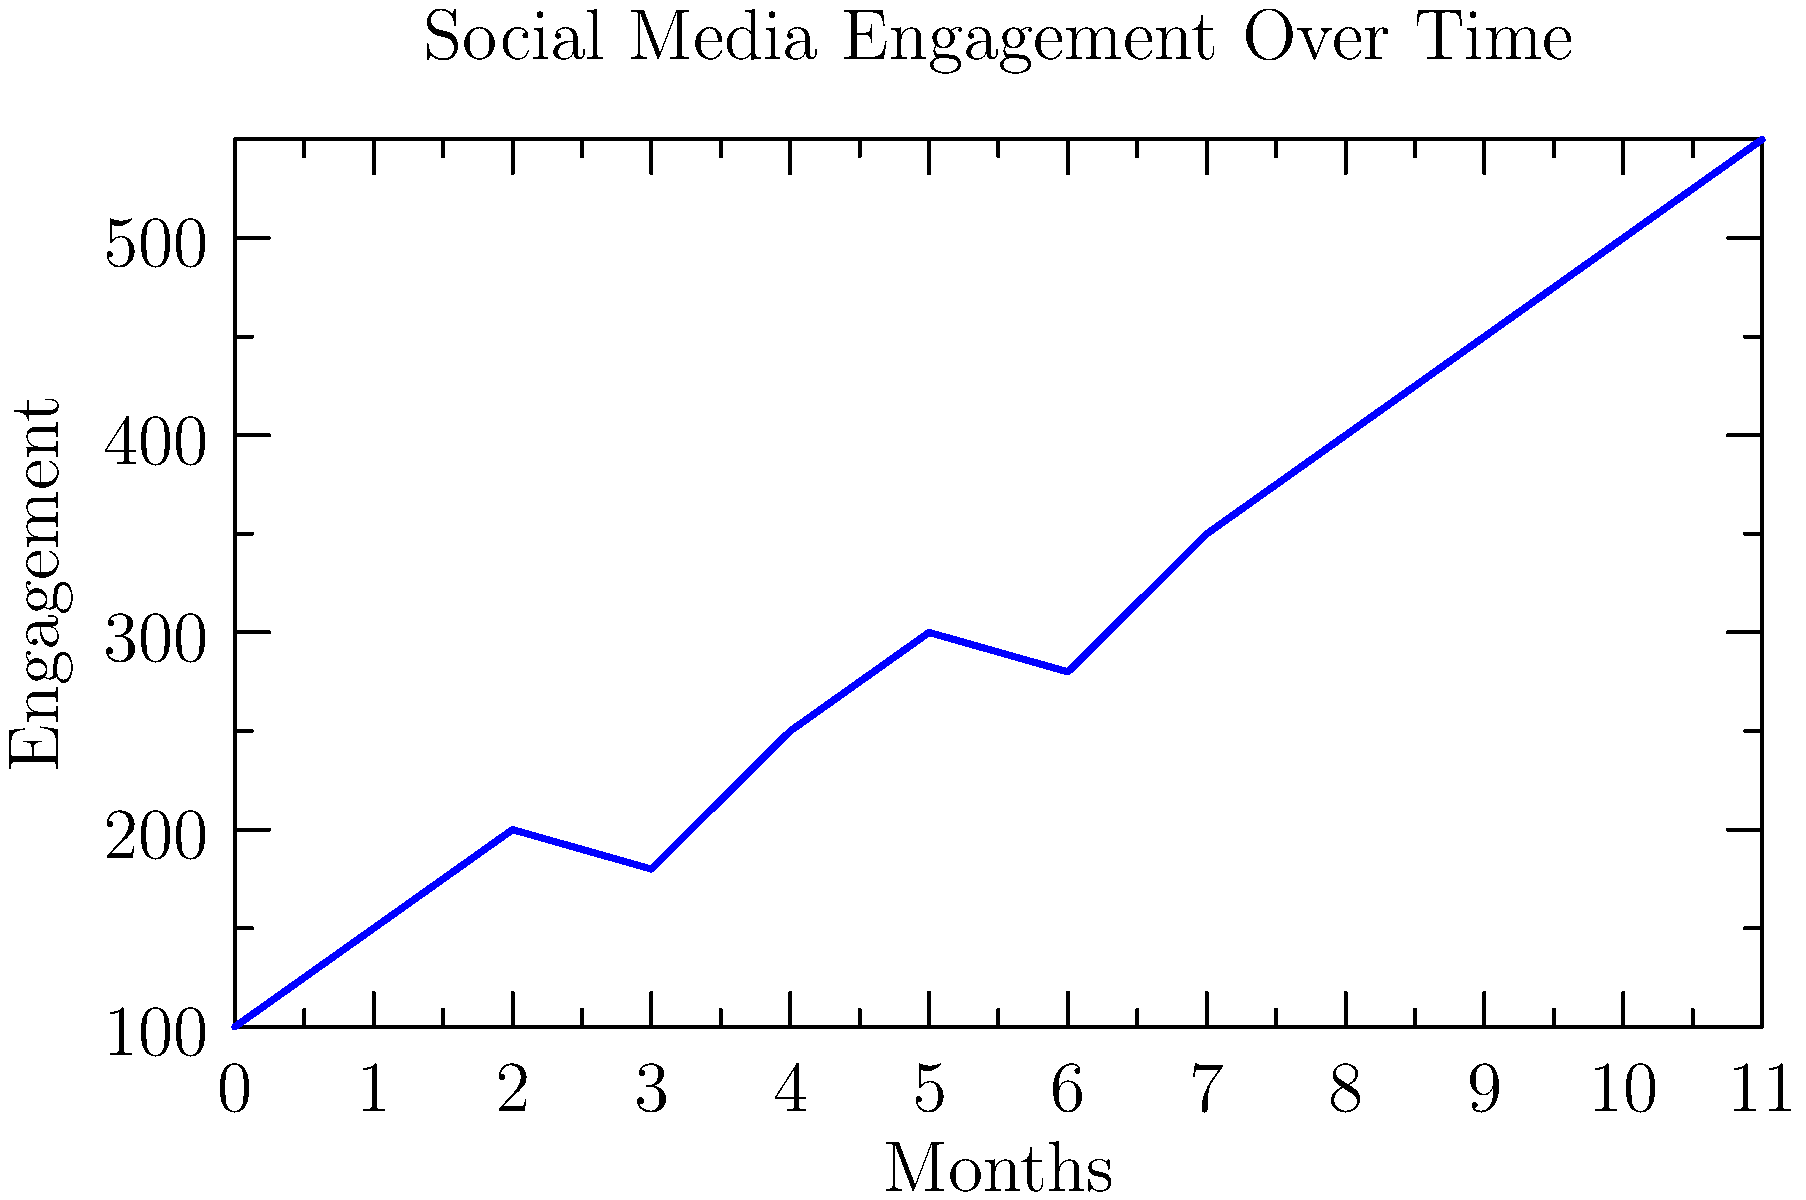As a publishing editor tracking an author's social media engagement, you notice a consistent upward trend over the past year. Based on the line graph showing monthly engagement, what is the approximate percentage increase in engagement from the first month to the last month? To calculate the percentage increase in engagement from the first month to the last month:

1. Identify the initial engagement (first month): 100
2. Identify the final engagement (last month): 550
3. Calculate the difference: 550 - 100 = 450
4. Divide the difference by the initial value: 450 / 100 = 4.5
5. Convert to percentage: 4.5 * 100 = 450%

The percentage increase is calculated using the formula:

$$ \text{Percentage Increase} = \frac{\text{Final Value} - \text{Initial Value}}{\text{Initial Value}} \times 100\% $$

$$ \text{Percentage Increase} = \frac{550 - 100}{100} \times 100\% = 450\% $$

This significant increase suggests that the author's unique writing style is gaining traction and reaching a broader audience over time.
Answer: 450% 